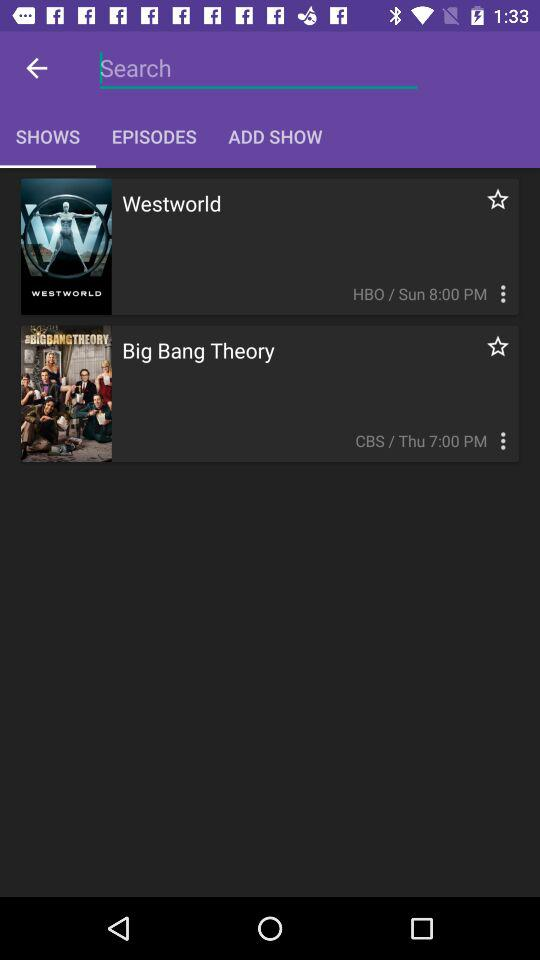On what day will "Westworld" telecast? "Westworld" will be telecast on Sunday. 